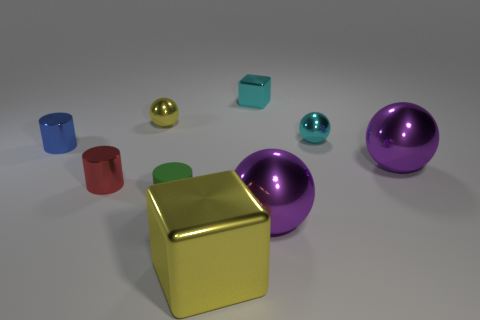Add 1 small cyan matte things. How many objects exist? 10 Subtract all green cylinders. How many cylinders are left? 2 Subtract all red metal cylinders. How many cylinders are left? 2 Subtract 2 cylinders. How many cylinders are left? 1 Subtract 0 gray cylinders. How many objects are left? 9 Subtract all cubes. How many objects are left? 7 Subtract all cyan spheres. Subtract all green cubes. How many spheres are left? 3 Subtract all blue cylinders. How many red spheres are left? 0 Subtract all tiny purple shiny cylinders. Subtract all purple objects. How many objects are left? 7 Add 1 purple shiny spheres. How many purple shiny spheres are left? 3 